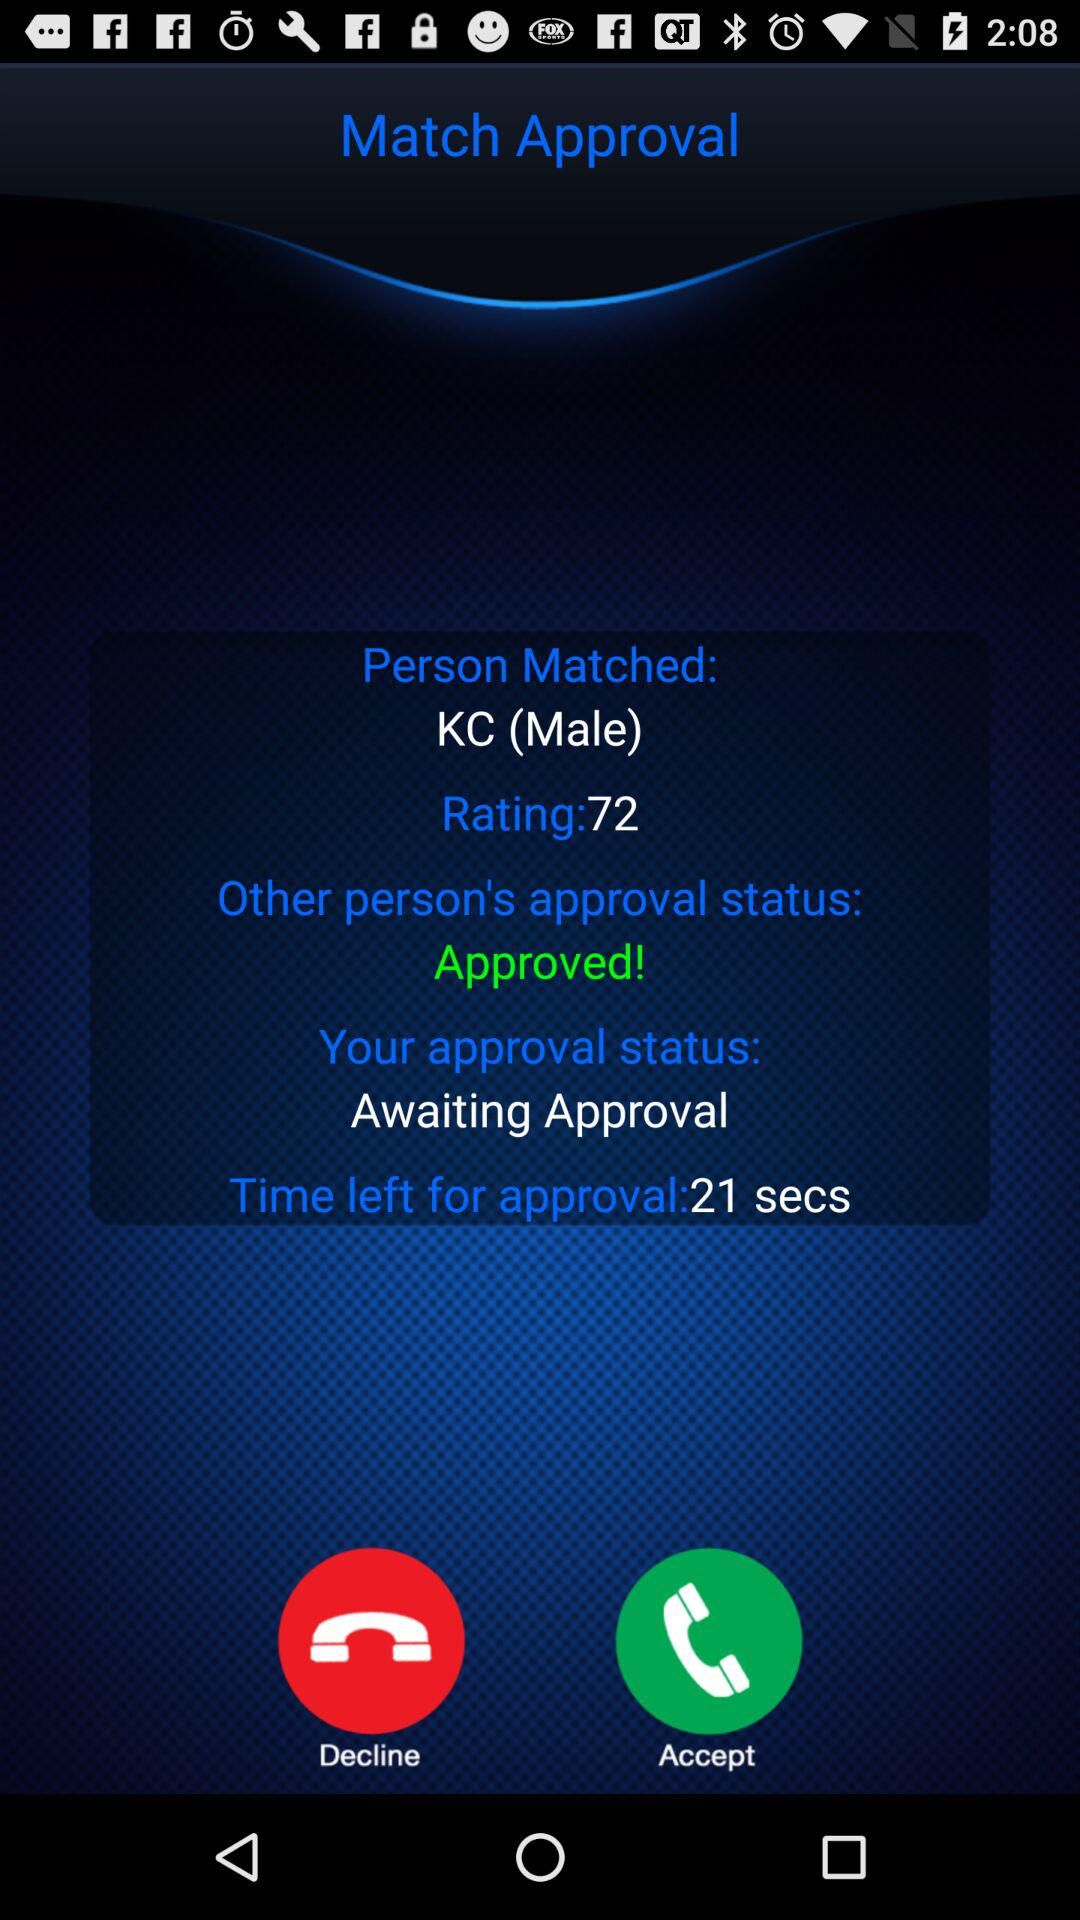What is the rating of the person I am matched with?
Answer the question using a single word or phrase. 72 